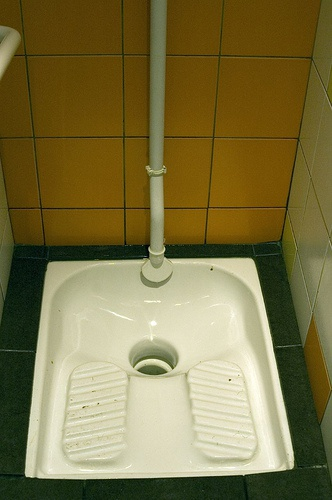Describe the objects in this image and their specific colors. I can see a toilet in olive, beige, and tan tones in this image. 